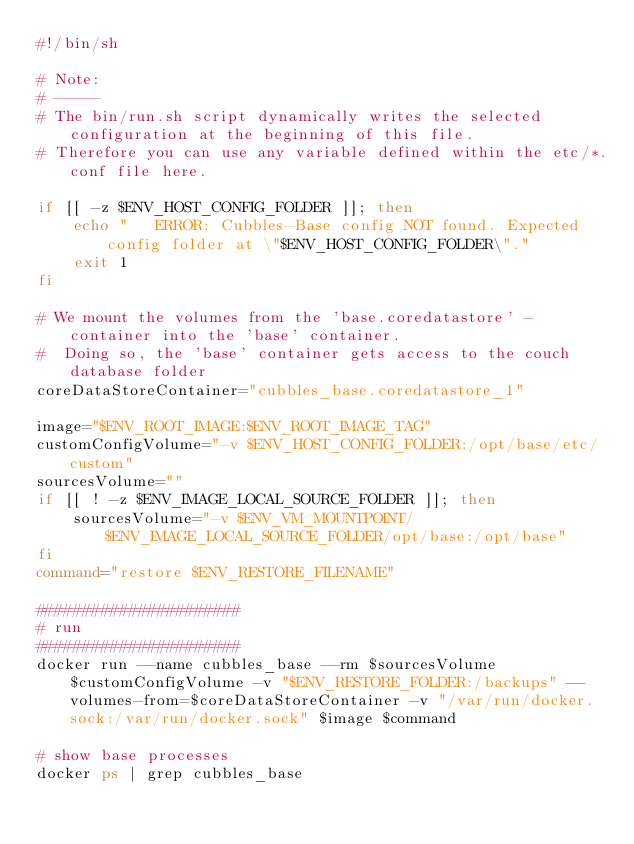Convert code to text. <code><loc_0><loc_0><loc_500><loc_500><_Bash_>#!/bin/sh

# Note:
# -----
# The bin/run.sh script dynamically writes the selected configuration at the beginning of this file.
# Therefore you can use any variable defined within the etc/*.conf file here.

if [[ -z $ENV_HOST_CONFIG_FOLDER ]]; then
    echo "   ERROR: Cubbles-Base config NOT found. Expected config folder at \"$ENV_HOST_CONFIG_FOLDER\"."
    exit 1
fi

# We mount the volumes from the 'base.coredatastore' -container into the 'base' container.
#  Doing so, the 'base' container gets access to the couch database folder
coreDataStoreContainer="cubbles_base.coredatastore_1"

image="$ENV_ROOT_IMAGE:$ENV_ROOT_IMAGE_TAG"
customConfigVolume="-v $ENV_HOST_CONFIG_FOLDER:/opt/base/etc/custom"
sourcesVolume=""
if [[ ! -z $ENV_IMAGE_LOCAL_SOURCE_FOLDER ]]; then
    sourcesVolume="-v $ENV_VM_MOUNTPOINT/$ENV_IMAGE_LOCAL_SOURCE_FOLDER/opt/base:/opt/base"
fi
command="restore $ENV_RESTORE_FILENAME"

######################
# run
######################
docker run --name cubbles_base --rm $sourcesVolume $customConfigVolume -v "$ENV_RESTORE_FOLDER:/backups" --volumes-from=$coreDataStoreContainer -v "/var/run/docker.sock:/var/run/docker.sock" $image $command

# show base processes
docker ps | grep cubbles_base

</code> 